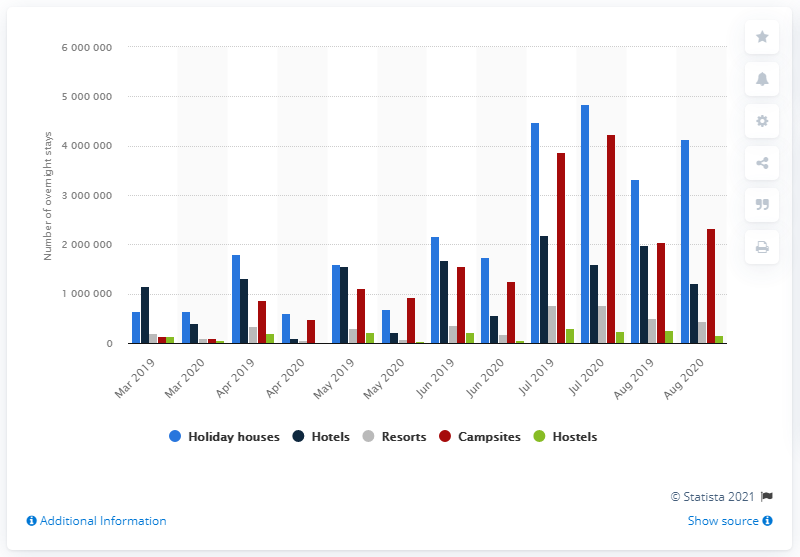Indicate a few pertinent items in this graphic. In August 2020, Denmark's hotels reported a total of 1,207,821 overnight stays. 